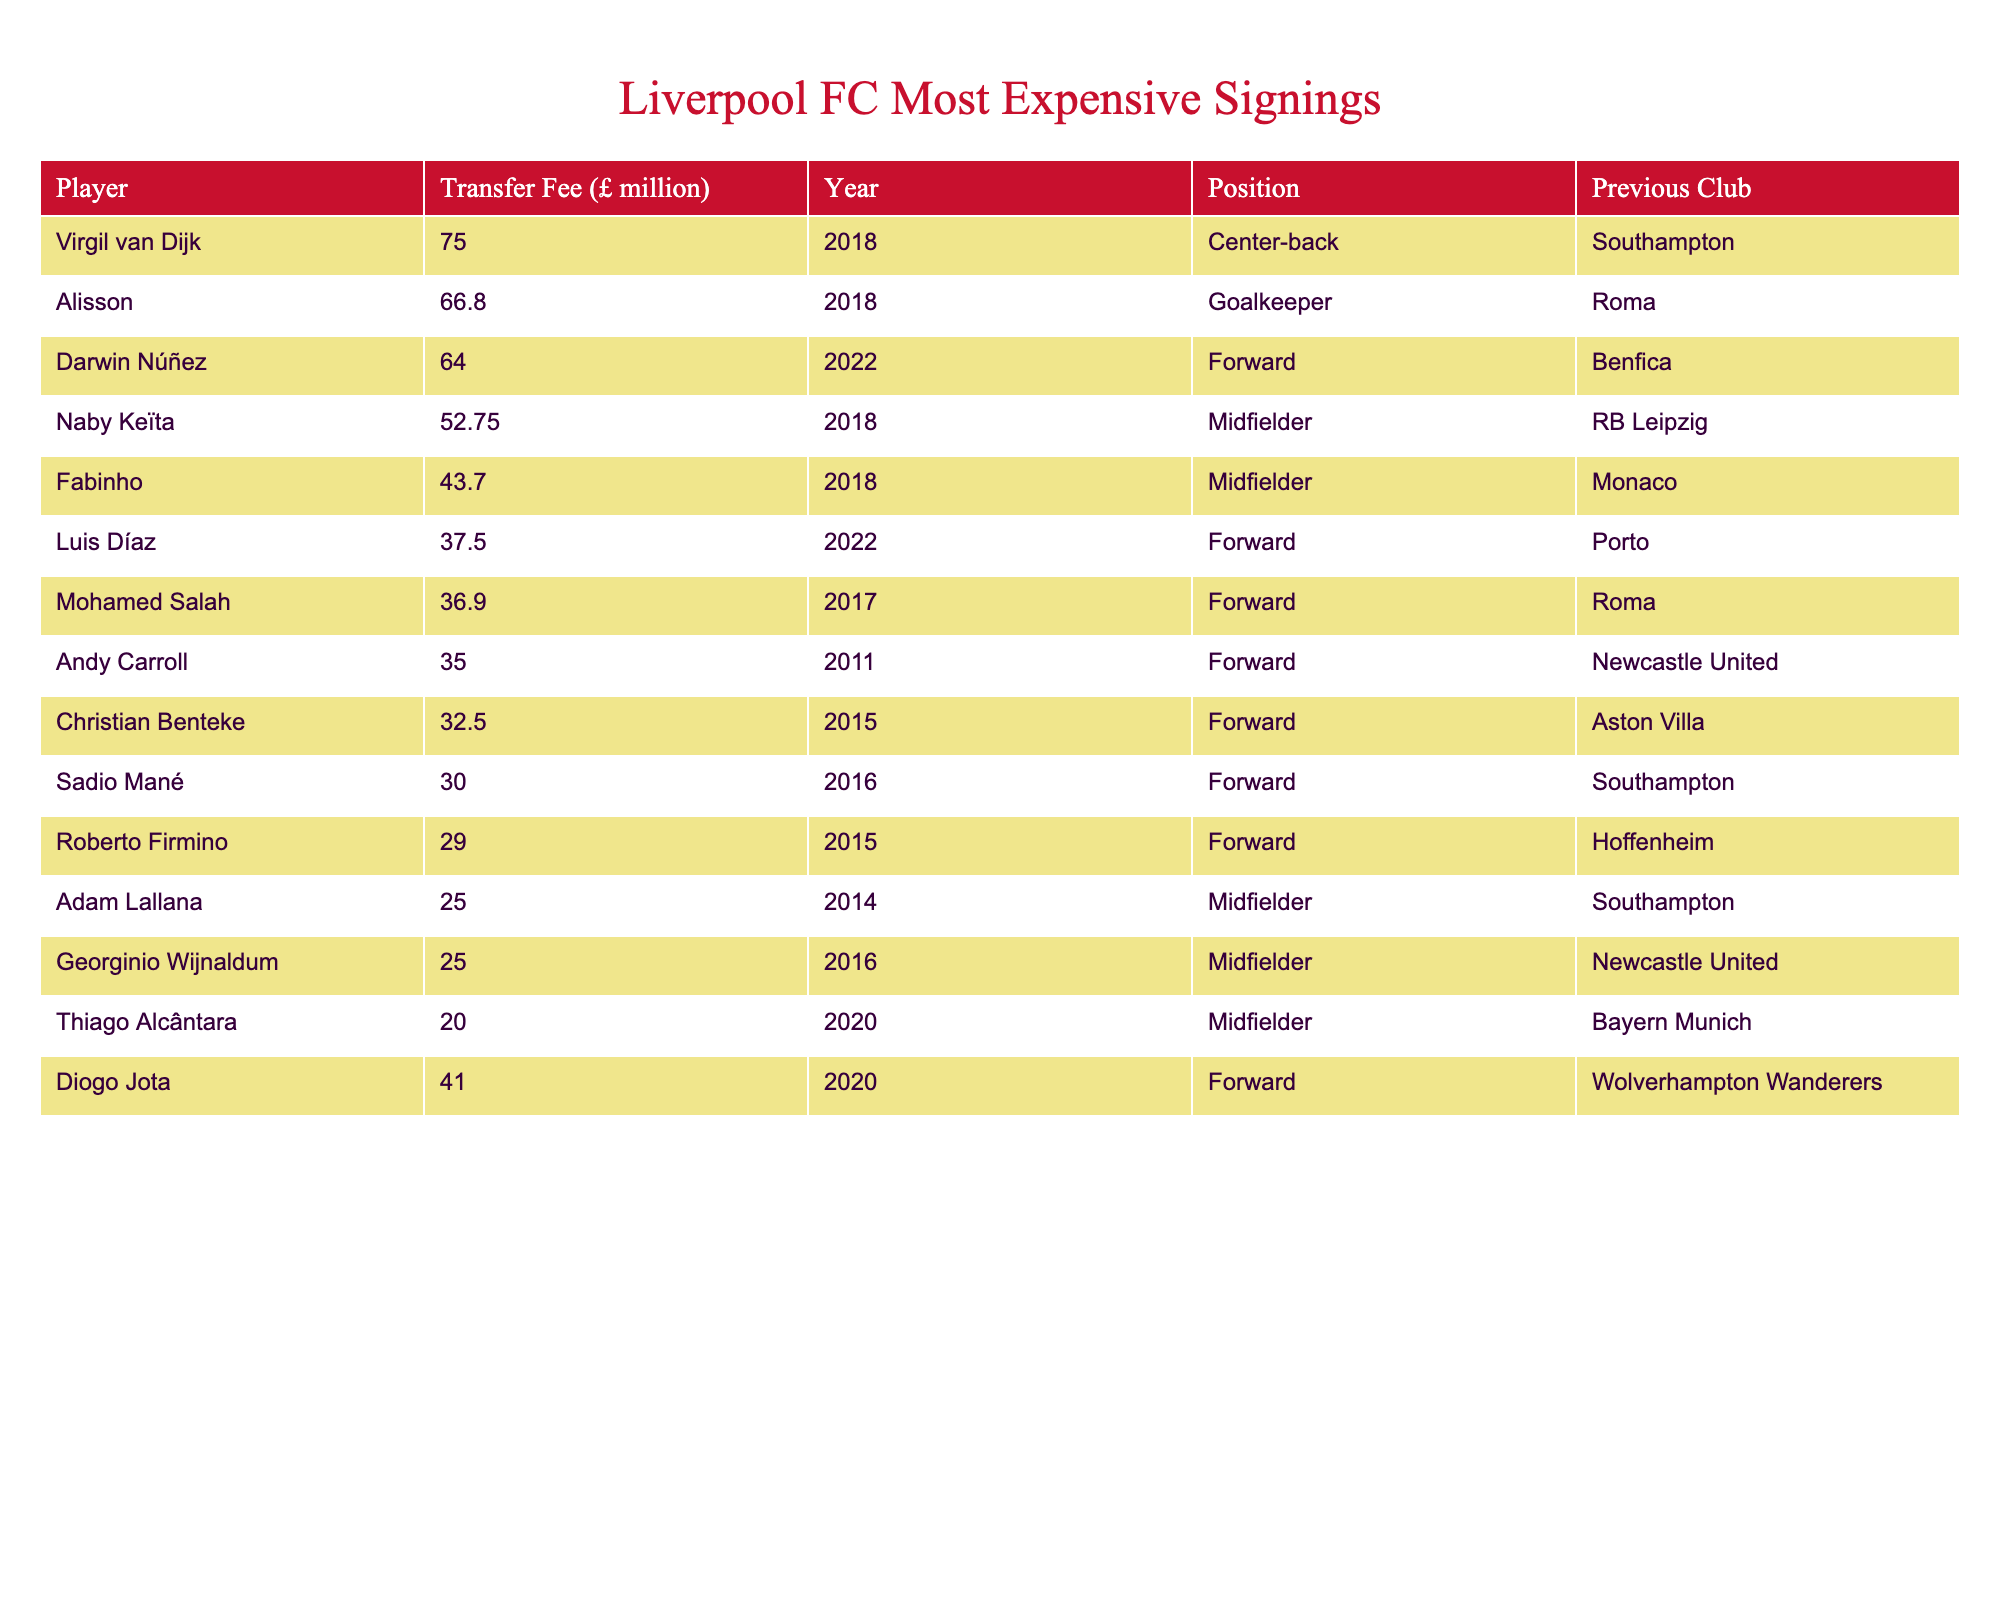What is the highest transfer fee paid for a Liverpool player? The highest transfer fee in the table is £75 million for Virgil van Dijk in 2018.
Answer: £75 million Which player was signed in 2022 for a fee of £64 million? The player signed in 2022 for £64 million is Darwin Núñez from Benfica.
Answer: Darwin Núñez How many players were signed for fees over £50 million? The players signed for fees over £50 million are Virgil van Dijk, Alisson, Darwin Núñez, and Naby Keïta. This totals four players.
Answer: 4 What position does Alisson play? According to the table, Alisson plays as a Goalkeeper.
Answer: Goalkeeper Is Thiago Alcântara the most expensive midfielder signed by Liverpool? No, Naby Keïta, who was signed for £52.75 million, is more expensive than Thiago Alcântara, who cost £20 million.
Answer: No What is the total fee spent on the top three most expensive signings? The total fee for the top three signings (Virgil van Dijk £75m, Alisson £66.8m, and Darwin Núñez £64m) is calculated as follows: 75 + 66.8 + 64 = £205.8 million.
Answer: £205.8 million Which club did Luis Díaz join Liverpool from? Luis Díaz joined Liverpool from Porto, as listed in the table.
Answer: Porto What is the average transfer fee of the five least expensive signings in the table? The five least expensive signings are Roberto Firmino (£29m), Sadio Mané (£30m), Christian Benteke (£32.5m), Andy Carroll (£35m), and Mohamed Salah (£36.9m). Their total is 29 + 30 + 32.5 + 35 + 36.9 = £163.4 million, and there are 5 players, so the average is 163.4/5 = £32.68 million.
Answer: £32.68 million In which year was Fabinho signed? Fabinho was signed in the year 2018, as stated in the table.
Answer: 2018 